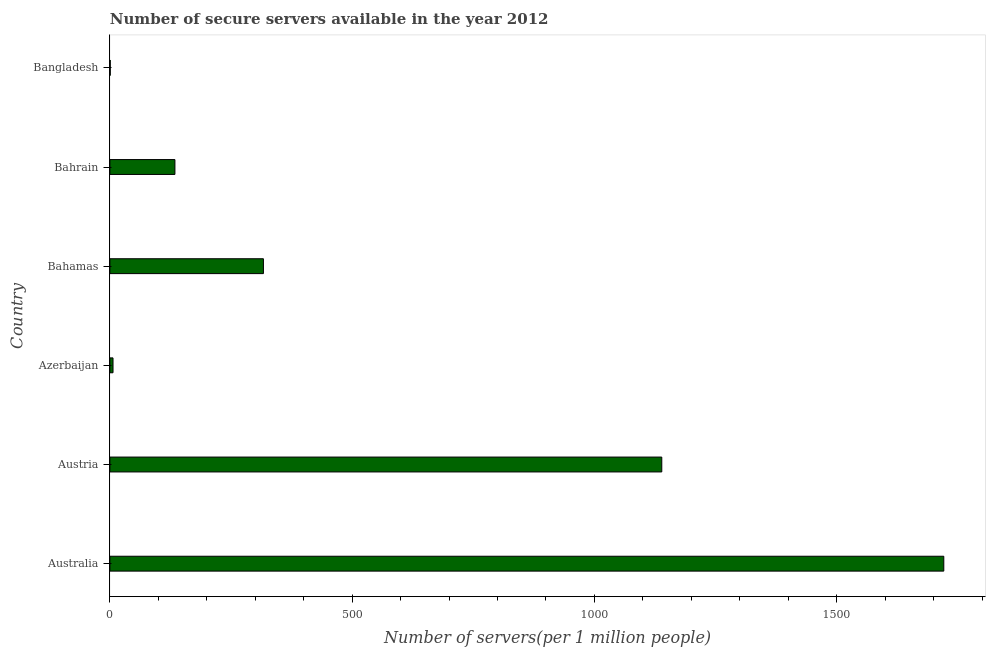Does the graph contain any zero values?
Keep it short and to the point. No. What is the title of the graph?
Give a very brief answer. Number of secure servers available in the year 2012. What is the label or title of the X-axis?
Your answer should be compact. Number of servers(per 1 million people). What is the label or title of the Y-axis?
Your response must be concise. Country. What is the number of secure internet servers in Bangladesh?
Give a very brief answer. 0.73. Across all countries, what is the maximum number of secure internet servers?
Make the answer very short. 1721.07. Across all countries, what is the minimum number of secure internet servers?
Provide a succinct answer. 0.73. In which country was the number of secure internet servers maximum?
Make the answer very short. Australia. In which country was the number of secure internet servers minimum?
Ensure brevity in your answer.  Bangladesh. What is the sum of the number of secure internet servers?
Your answer should be very brief. 3318.38. What is the difference between the number of secure internet servers in Bahrain and Bangladesh?
Keep it short and to the point. 133.5. What is the average number of secure internet servers per country?
Give a very brief answer. 553.06. What is the median number of secure internet servers?
Provide a succinct answer. 225.55. In how many countries, is the number of secure internet servers greater than 1400 ?
Your response must be concise. 1. What is the ratio of the number of secure internet servers in Australia to that in Bahamas?
Make the answer very short. 5.43. What is the difference between the highest and the second highest number of secure internet servers?
Offer a very short reply. 582.04. What is the difference between the highest and the lowest number of secure internet servers?
Provide a succinct answer. 1720.35. In how many countries, is the number of secure internet servers greater than the average number of secure internet servers taken over all countries?
Your answer should be very brief. 2. How many countries are there in the graph?
Your answer should be compact. 6. What is the difference between two consecutive major ticks on the X-axis?
Ensure brevity in your answer.  500. What is the Number of servers(per 1 million people) in Australia?
Offer a very short reply. 1721.07. What is the Number of servers(per 1 million people) in Austria?
Keep it short and to the point. 1139.03. What is the Number of servers(per 1 million people) in Azerbaijan?
Provide a succinct answer. 6.45. What is the Number of servers(per 1 million people) of Bahamas?
Your answer should be compact. 316.87. What is the Number of servers(per 1 million people) in Bahrain?
Your response must be concise. 134.23. What is the Number of servers(per 1 million people) of Bangladesh?
Offer a terse response. 0.73. What is the difference between the Number of servers(per 1 million people) in Australia and Austria?
Keep it short and to the point. 582.05. What is the difference between the Number of servers(per 1 million people) in Australia and Azerbaijan?
Your answer should be compact. 1714.62. What is the difference between the Number of servers(per 1 million people) in Australia and Bahamas?
Provide a short and direct response. 1404.2. What is the difference between the Number of servers(per 1 million people) in Australia and Bahrain?
Keep it short and to the point. 1586.85. What is the difference between the Number of servers(per 1 million people) in Australia and Bangladesh?
Make the answer very short. 1720.35. What is the difference between the Number of servers(per 1 million people) in Austria and Azerbaijan?
Keep it short and to the point. 1132.57. What is the difference between the Number of servers(per 1 million people) in Austria and Bahamas?
Offer a very short reply. 822.15. What is the difference between the Number of servers(per 1 million people) in Austria and Bahrain?
Give a very brief answer. 1004.8. What is the difference between the Number of servers(per 1 million people) in Austria and Bangladesh?
Offer a terse response. 1138.3. What is the difference between the Number of servers(per 1 million people) in Azerbaijan and Bahamas?
Provide a short and direct response. -310.42. What is the difference between the Number of servers(per 1 million people) in Azerbaijan and Bahrain?
Your response must be concise. -127.77. What is the difference between the Number of servers(per 1 million people) in Azerbaijan and Bangladesh?
Give a very brief answer. 5.73. What is the difference between the Number of servers(per 1 million people) in Bahamas and Bahrain?
Ensure brevity in your answer.  182.65. What is the difference between the Number of servers(per 1 million people) in Bahamas and Bangladesh?
Give a very brief answer. 316.15. What is the difference between the Number of servers(per 1 million people) in Bahrain and Bangladesh?
Give a very brief answer. 133.5. What is the ratio of the Number of servers(per 1 million people) in Australia to that in Austria?
Give a very brief answer. 1.51. What is the ratio of the Number of servers(per 1 million people) in Australia to that in Azerbaijan?
Your response must be concise. 266.64. What is the ratio of the Number of servers(per 1 million people) in Australia to that in Bahamas?
Your answer should be compact. 5.43. What is the ratio of the Number of servers(per 1 million people) in Australia to that in Bahrain?
Your answer should be very brief. 12.82. What is the ratio of the Number of servers(per 1 million people) in Australia to that in Bangladesh?
Your answer should be compact. 2364.68. What is the ratio of the Number of servers(per 1 million people) in Austria to that in Azerbaijan?
Offer a terse response. 176.47. What is the ratio of the Number of servers(per 1 million people) in Austria to that in Bahamas?
Provide a succinct answer. 3.6. What is the ratio of the Number of servers(per 1 million people) in Austria to that in Bahrain?
Ensure brevity in your answer.  8.49. What is the ratio of the Number of servers(per 1 million people) in Austria to that in Bangladesh?
Keep it short and to the point. 1564.98. What is the ratio of the Number of servers(per 1 million people) in Azerbaijan to that in Bahrain?
Provide a short and direct response. 0.05. What is the ratio of the Number of servers(per 1 million people) in Azerbaijan to that in Bangladesh?
Make the answer very short. 8.87. What is the ratio of the Number of servers(per 1 million people) in Bahamas to that in Bahrain?
Ensure brevity in your answer.  2.36. What is the ratio of the Number of servers(per 1 million people) in Bahamas to that in Bangladesh?
Provide a succinct answer. 435.37. What is the ratio of the Number of servers(per 1 million people) in Bahrain to that in Bangladesh?
Provide a succinct answer. 184.42. 